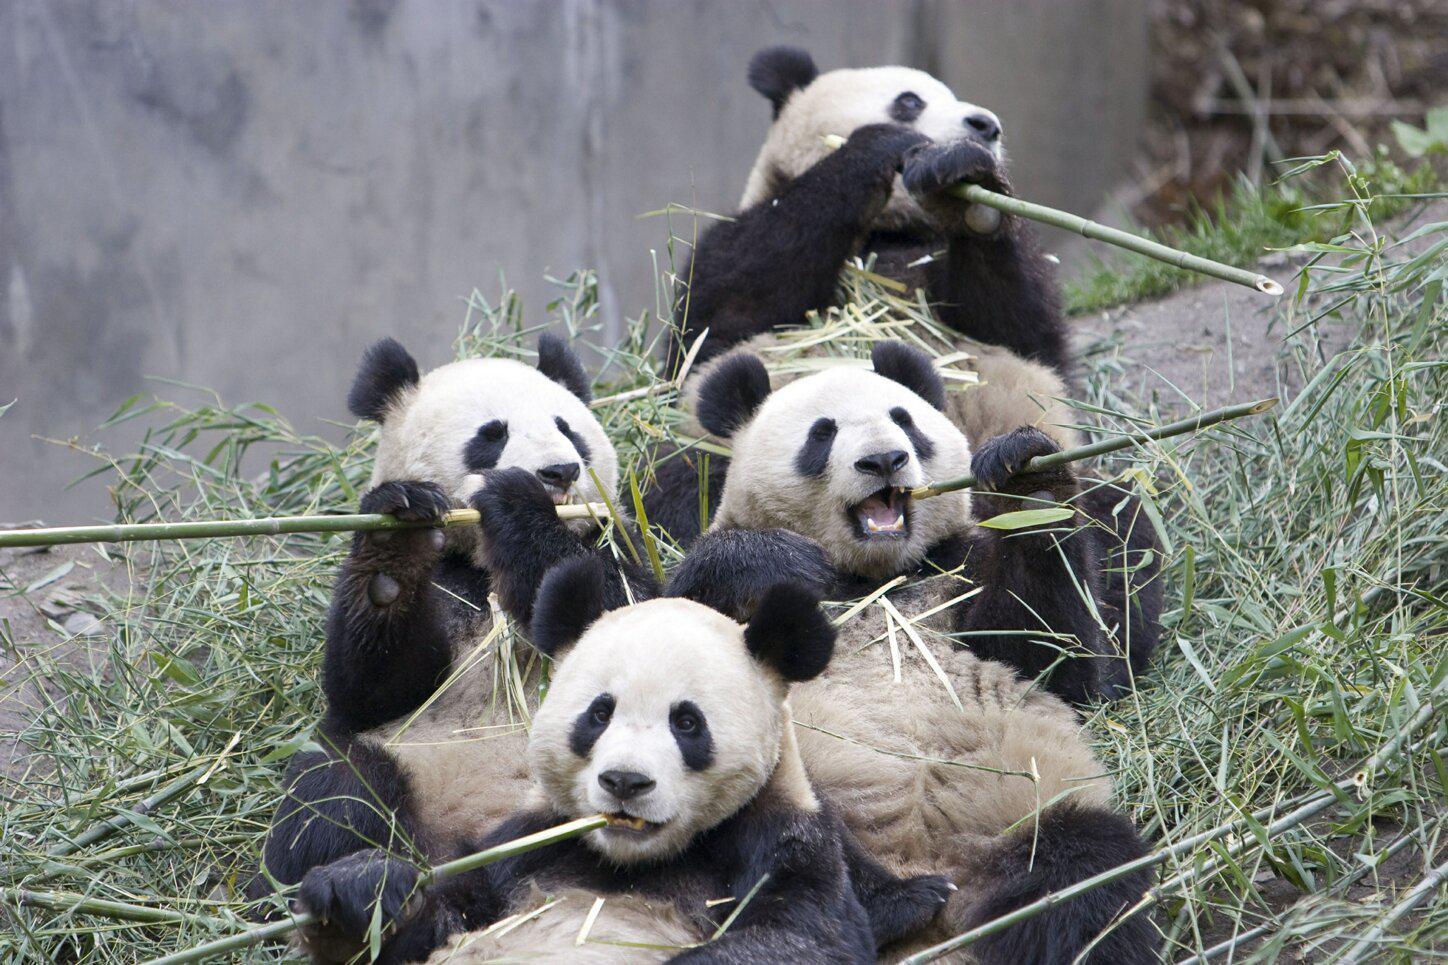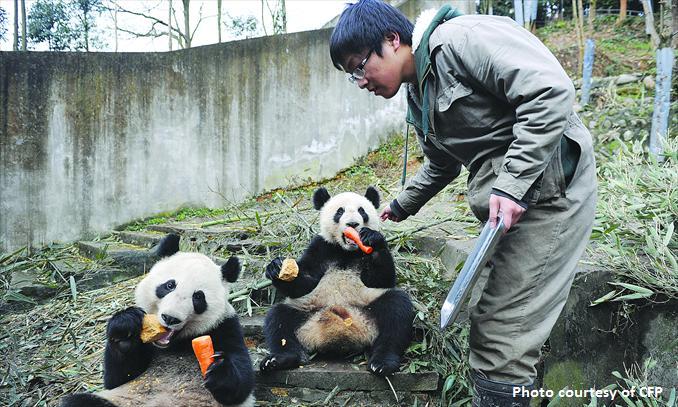The first image is the image on the left, the second image is the image on the right. Evaluate the accuracy of this statement regarding the images: "One image features one forward-facing panda chewing green leaves, with the paw on the left raised and curled over.". Is it true? Answer yes or no. No. The first image is the image on the left, the second image is the image on the right. Examine the images to the left and right. Is the description "There are two pandas eating." accurate? Answer yes or no. No. 